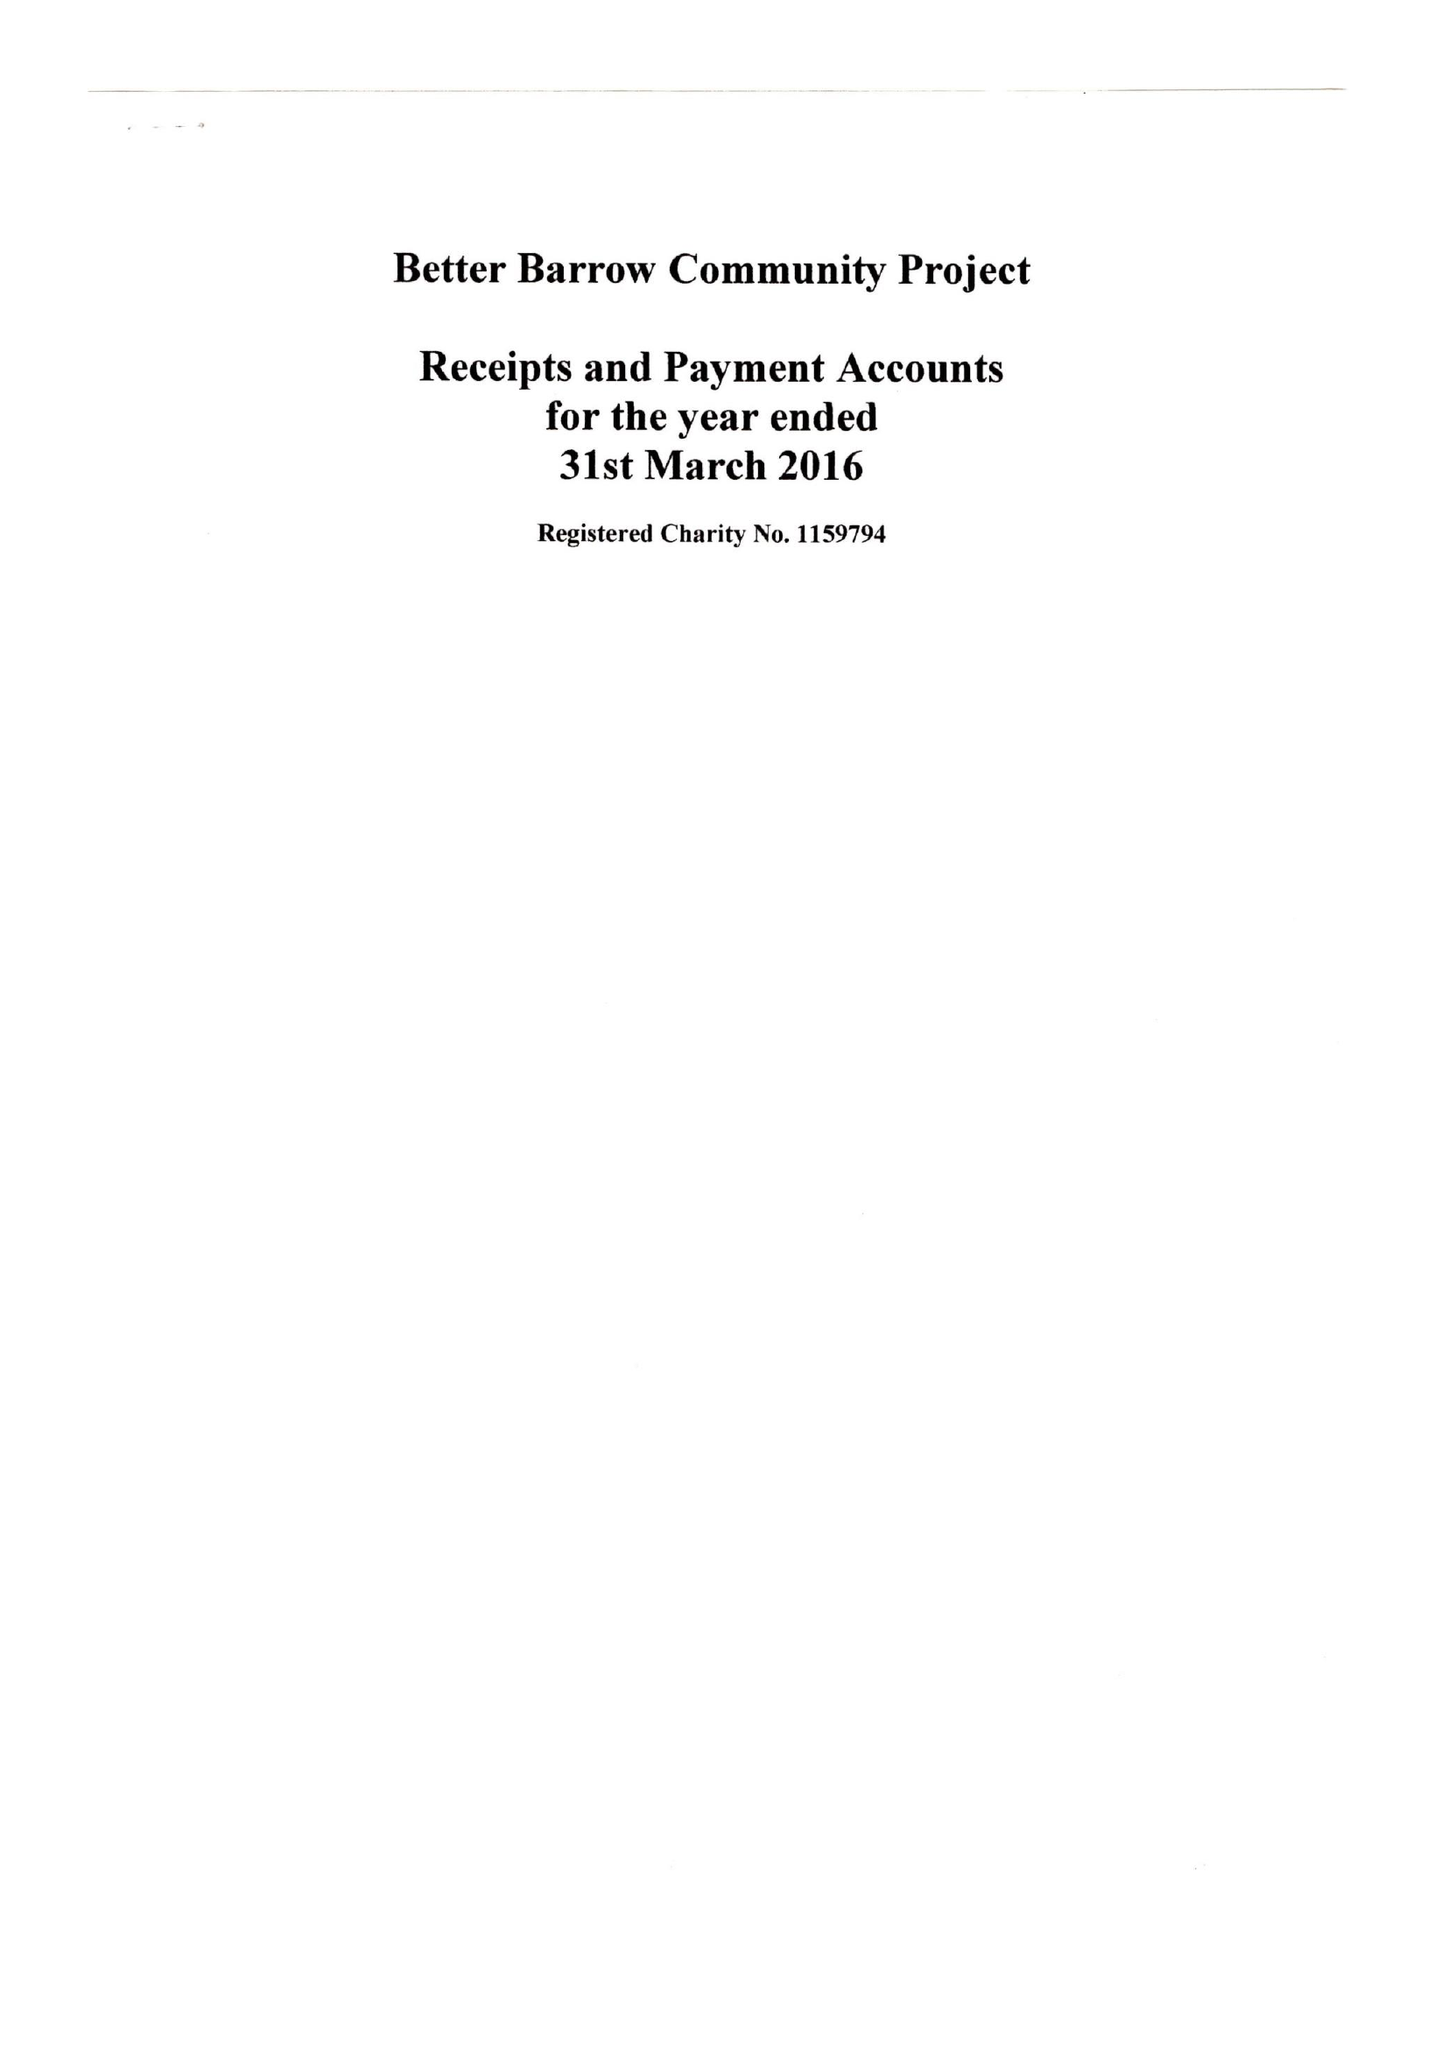What is the value for the income_annually_in_british_pounds?
Answer the question using a single word or phrase. 3366.00 